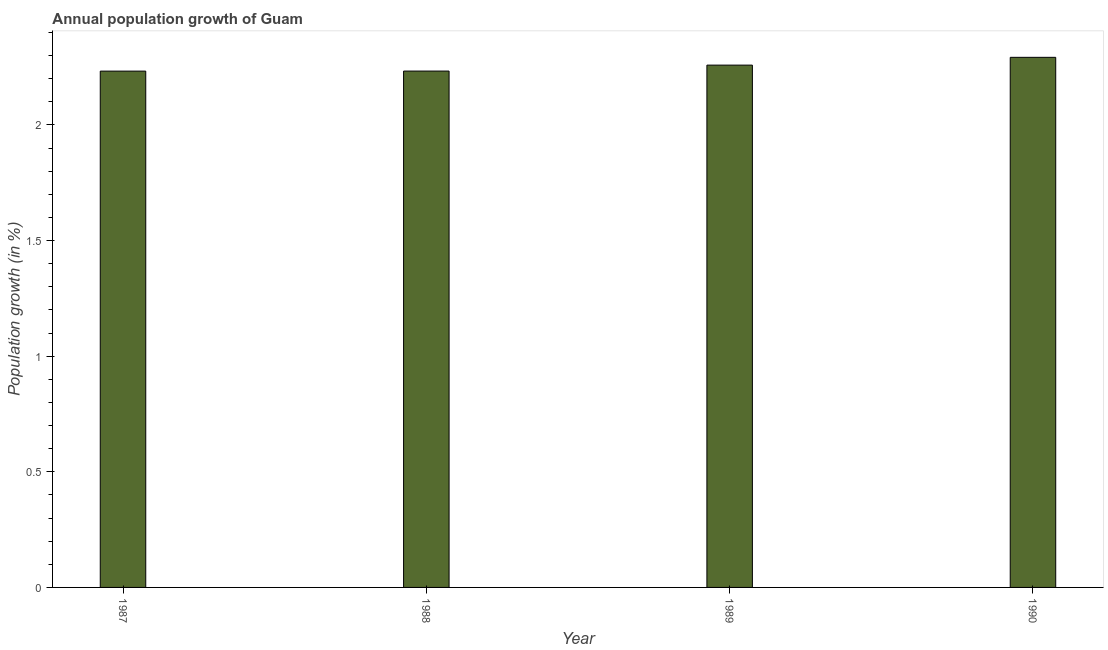Does the graph contain any zero values?
Ensure brevity in your answer.  No. Does the graph contain grids?
Your answer should be very brief. No. What is the title of the graph?
Keep it short and to the point. Annual population growth of Guam. What is the label or title of the Y-axis?
Offer a very short reply. Population growth (in %). What is the population growth in 1989?
Your response must be concise. 2.26. Across all years, what is the maximum population growth?
Keep it short and to the point. 2.29. Across all years, what is the minimum population growth?
Make the answer very short. 2.23. In which year was the population growth maximum?
Offer a terse response. 1990. What is the sum of the population growth?
Offer a terse response. 9.02. What is the difference between the population growth in 1987 and 1990?
Your answer should be compact. -0.06. What is the average population growth per year?
Your answer should be compact. 2.25. What is the median population growth?
Provide a succinct answer. 2.25. Do a majority of the years between 1987 and 1988 (inclusive) have population growth greater than 1.6 %?
Keep it short and to the point. Yes. What is the ratio of the population growth in 1989 to that in 1990?
Your response must be concise. 0.98. Is the population growth in 1987 less than that in 1988?
Ensure brevity in your answer.  Yes. What is the difference between the highest and the second highest population growth?
Give a very brief answer. 0.03. What is the difference between the highest and the lowest population growth?
Give a very brief answer. 0.06. How many years are there in the graph?
Keep it short and to the point. 4. What is the Population growth (in %) of 1987?
Ensure brevity in your answer.  2.23. What is the Population growth (in %) of 1988?
Offer a terse response. 2.23. What is the Population growth (in %) in 1989?
Provide a short and direct response. 2.26. What is the Population growth (in %) in 1990?
Your answer should be compact. 2.29. What is the difference between the Population growth (in %) in 1987 and 1988?
Keep it short and to the point. -0. What is the difference between the Population growth (in %) in 1987 and 1989?
Offer a very short reply. -0.03. What is the difference between the Population growth (in %) in 1987 and 1990?
Provide a succinct answer. -0.06. What is the difference between the Population growth (in %) in 1988 and 1989?
Provide a short and direct response. -0.03. What is the difference between the Population growth (in %) in 1988 and 1990?
Offer a terse response. -0.06. What is the difference between the Population growth (in %) in 1989 and 1990?
Ensure brevity in your answer.  -0.03. What is the ratio of the Population growth (in %) in 1987 to that in 1989?
Provide a short and direct response. 0.99. What is the ratio of the Population growth (in %) in 1987 to that in 1990?
Your answer should be very brief. 0.97. What is the ratio of the Population growth (in %) in 1988 to that in 1989?
Ensure brevity in your answer.  0.99. What is the ratio of the Population growth (in %) in 1988 to that in 1990?
Make the answer very short. 0.97. What is the ratio of the Population growth (in %) in 1989 to that in 1990?
Your answer should be compact. 0.98. 